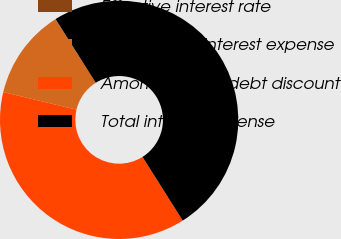Convert chart to OTSL. <chart><loc_0><loc_0><loc_500><loc_500><pie_chart><fcel>Effective interest rate<fcel>Contractual interest expense<fcel>Amortization of debt discount<fcel>Total interest expense<nl><fcel>0.02%<fcel>12.28%<fcel>37.71%<fcel>49.99%<nl></chart> 